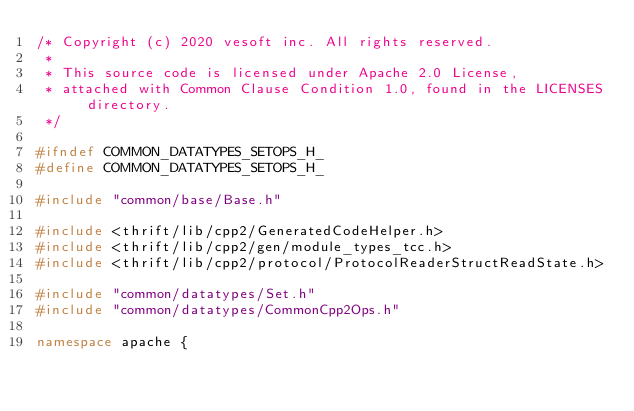<code> <loc_0><loc_0><loc_500><loc_500><_C++_>/* Copyright (c) 2020 vesoft inc. All rights reserved.
 *
 * This source code is licensed under Apache 2.0 License,
 * attached with Common Clause Condition 1.0, found in the LICENSES directory.
 */

#ifndef COMMON_DATATYPES_SETOPS_H_
#define COMMON_DATATYPES_SETOPS_H_

#include "common/base/Base.h"

#include <thrift/lib/cpp2/GeneratedCodeHelper.h>
#include <thrift/lib/cpp2/gen/module_types_tcc.h>
#include <thrift/lib/cpp2/protocol/ProtocolReaderStructReadState.h>

#include "common/datatypes/Set.h"
#include "common/datatypes/CommonCpp2Ops.h"

namespace apache {</code> 